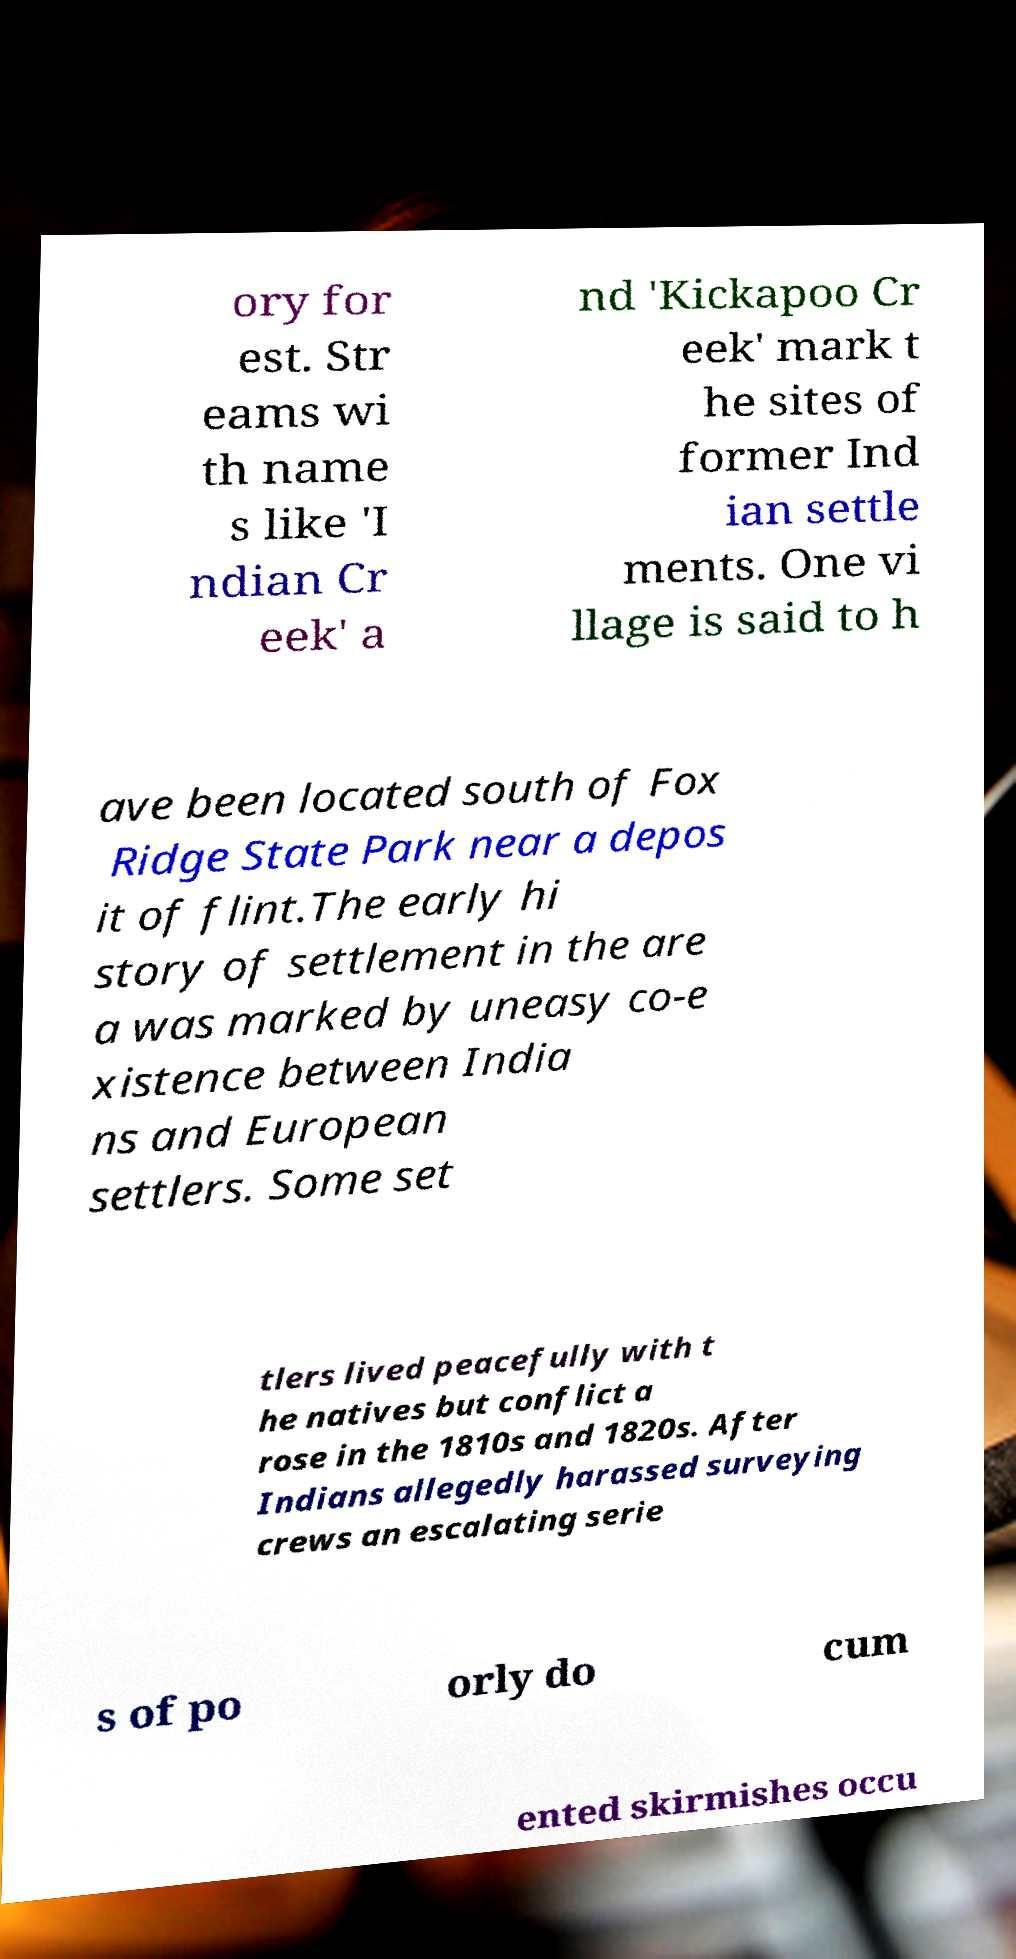There's text embedded in this image that I need extracted. Can you transcribe it verbatim? ory for est. Str eams wi th name s like 'I ndian Cr eek' a nd 'Kickapoo Cr eek' mark t he sites of former Ind ian settle ments. One vi llage is said to h ave been located south of Fox Ridge State Park near a depos it of flint.The early hi story of settlement in the are a was marked by uneasy co-e xistence between India ns and European settlers. Some set tlers lived peacefully with t he natives but conflict a rose in the 1810s and 1820s. After Indians allegedly harassed surveying crews an escalating serie s of po orly do cum ented skirmishes occu 